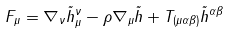Convert formula to latex. <formula><loc_0><loc_0><loc_500><loc_500>F _ { \mu } = \nabla _ { \nu } \tilde { h } _ { \mu } ^ { \nu } - \rho \nabla _ { \mu } \tilde { h } + T _ { ( \mu \alpha \beta ) } \tilde { h } ^ { \alpha \beta }</formula> 